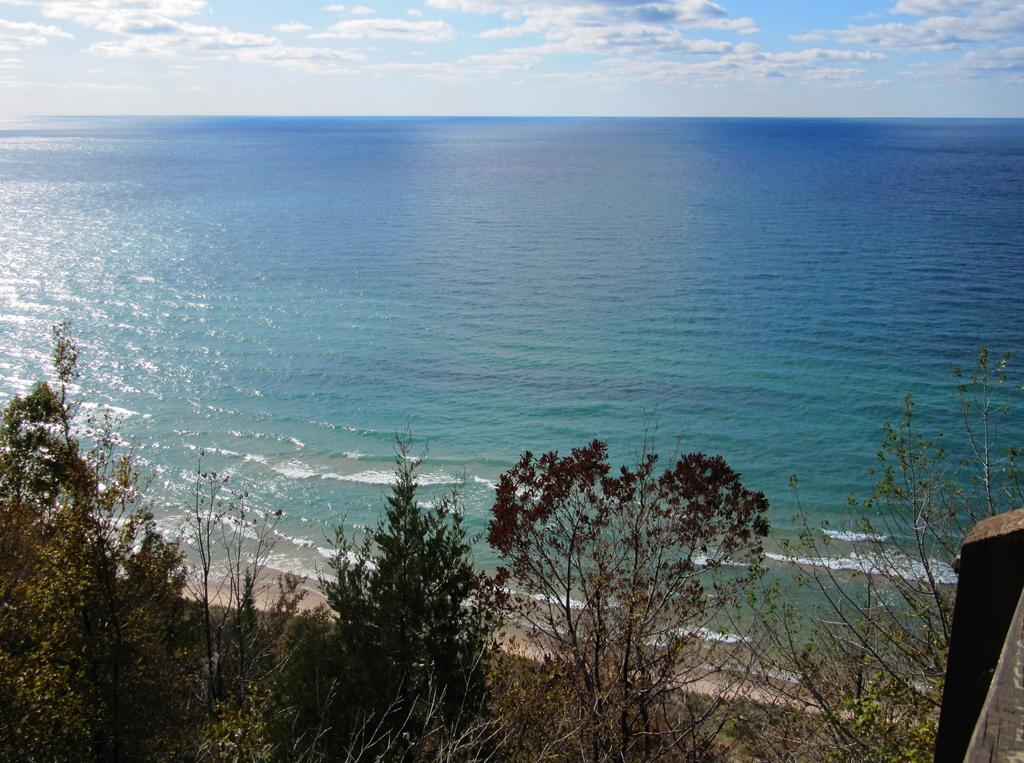What type of vegetation is present at the bottom of the image? There are trees at the bottom of the image. What natural feature can be seen at the center of the image? There is a river at the center of the image. What is visible in the background of the image? There is a sky visible in the background of the image. How many legs can be seen on the cream in the image? There is no cream present in the image, and therefore no legs can be seen on it. 